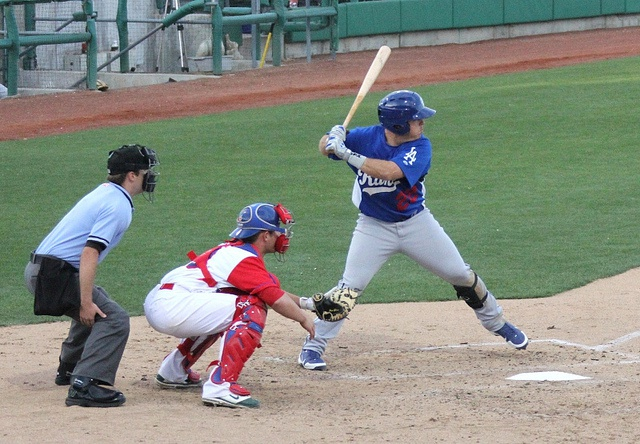Describe the objects in this image and their specific colors. I can see people in teal, darkgray, navy, and gray tones, people in teal, lavender, darkgray, brown, and gray tones, people in teal, black, gray, and lightblue tones, baseball glove in teal, black, gray, darkgray, and beige tones, and baseball bat in teal, lightgray, tan, gray, and darkgray tones in this image. 